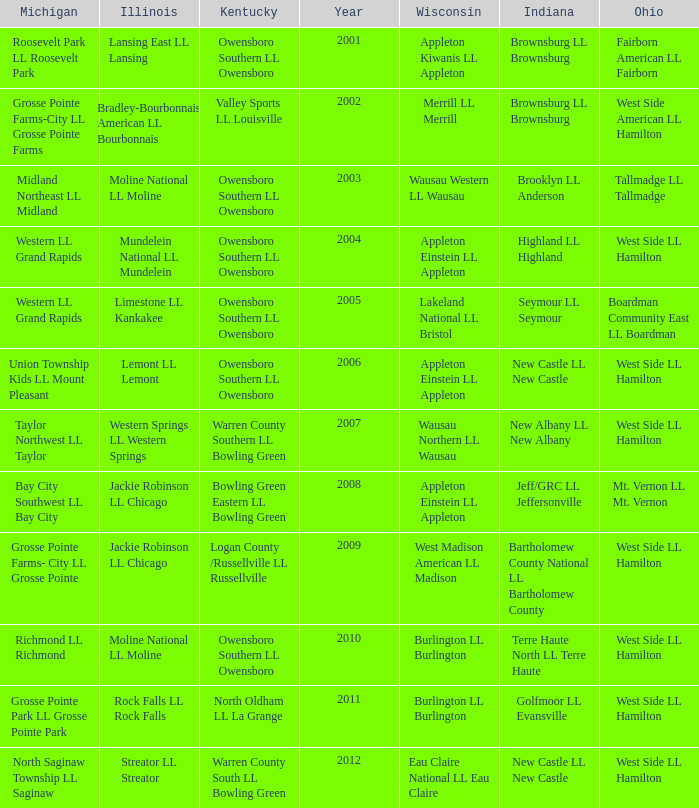What was the little league team from Kentucky when the little league team from Michigan was Grosse Pointe Farms-City LL Grosse Pointe Farms?  Valley Sports LL Louisville. 